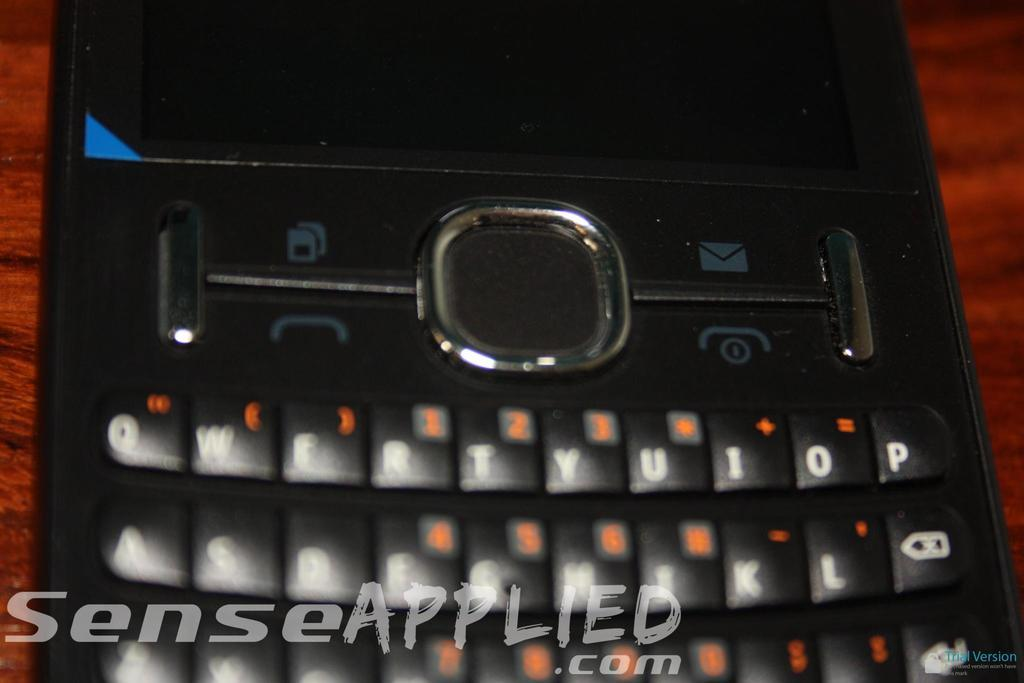<image>
Describe the image concisely. A black cell phone on a wooden table with the text senseapplied.com on the image. 